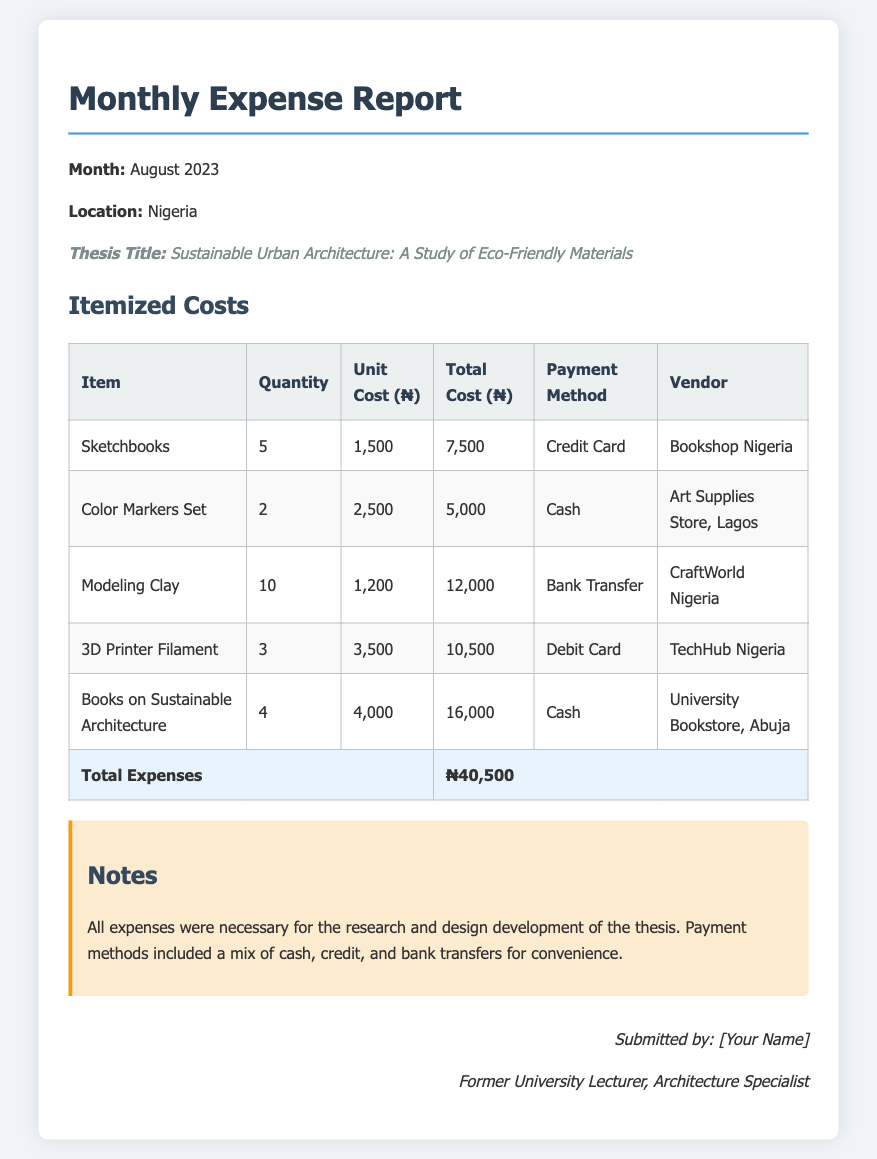What is the month of this report? The report specifies that it covers the expenses for August 2023.
Answer: August 2023 What is the total cost of Sketchbooks? The document indicates that the total cost for Sketchbooks is ₦7,500, calculated from the unit cost and quantity.
Answer: ₦7,500 How many items were purchased from Art Supplies Store, Lagos? The table shows that 2 Color Markers Sets were acquired from this vendor.
Answer: 2 What payment method was used for the Modeling Clay? According to the table, the payment method for the Modeling Clay was Bank Transfer.
Answer: Bank Transfer Which thesis title is mentioned in the report? The report includes the thesis title "Sustainable Urban Architecture: A Study of Eco-Friendly Materials."
Answer: Sustainable Urban Architecture: A Study of Eco-Friendly Materials What is the total amount spent on research materials and supplies? The document summarizes the total expenses as ₦40,500 for all items listed.
Answer: ₦40,500 How many 3D Printer Filaments were purchased? The itemized costs reveal that 3 units of 3D Printer Filament were bought.
Answer: 3 What type of materials does the thesis focus on? The thesis focuses on "Eco-Friendly Materials," as stated in the title.
Answer: Eco-Friendly Materials What was the vendor for the Books on Sustainable Architecture? The document specifies that these books were acquired from the University Bookstore, Abuja.
Answer: University Bookstore, Abuja 